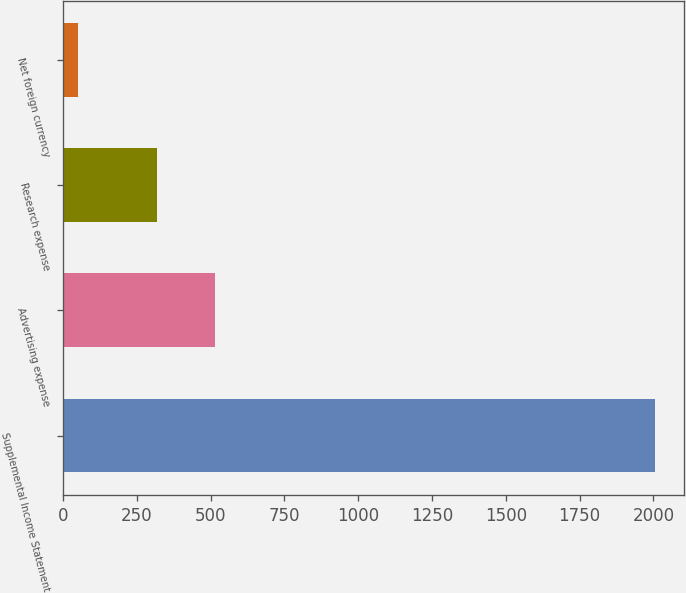Convert chart. <chart><loc_0><loc_0><loc_500><loc_500><bar_chart><fcel>Supplemental Income Statement<fcel>Advertising expense<fcel>Research expense<fcel>Net foreign currency<nl><fcel>2005<fcel>515<fcel>319.5<fcel>50<nl></chart> 